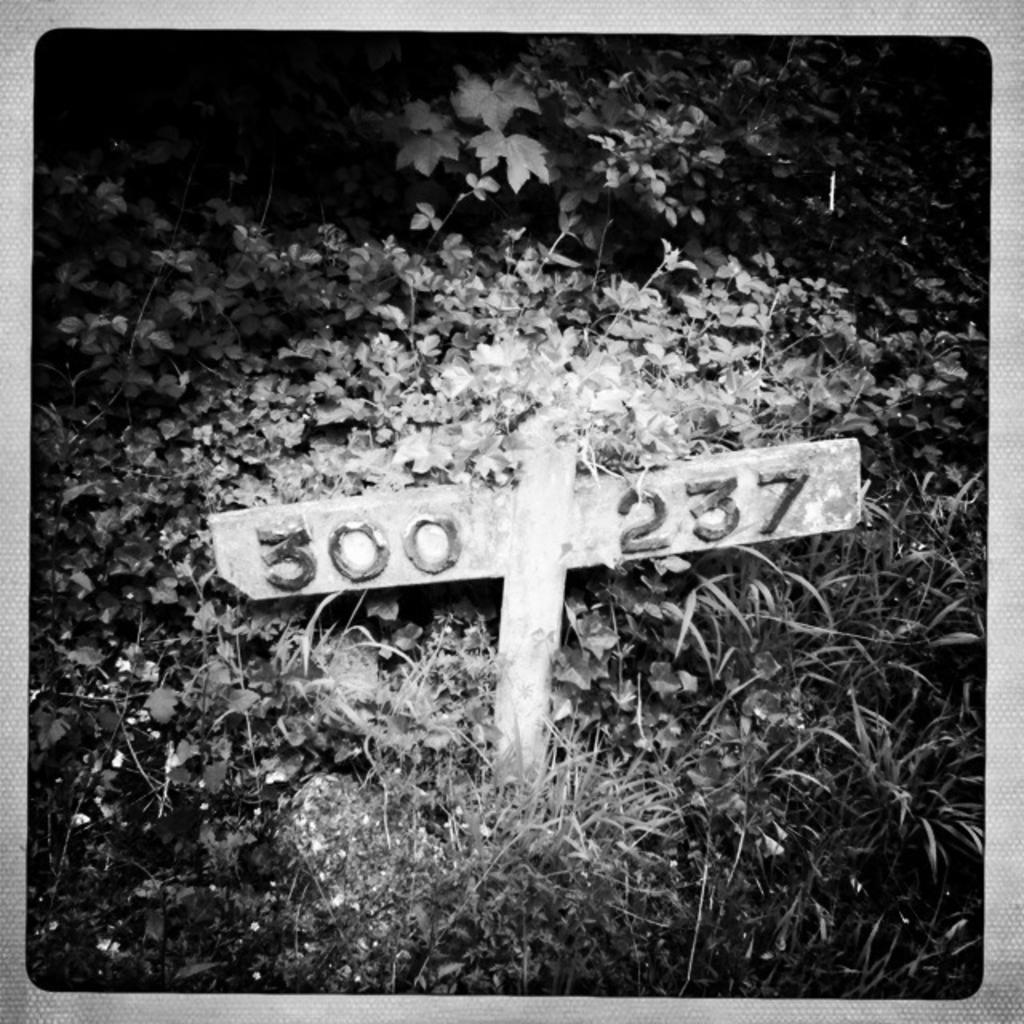Provide a one-sentence caption for the provided image. Two pieces of wood form a rudimentary sign noting the numbers "300 237" in the foliage. 